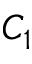Convert formula to latex. <formula><loc_0><loc_0><loc_500><loc_500>C _ { 1 }</formula> 